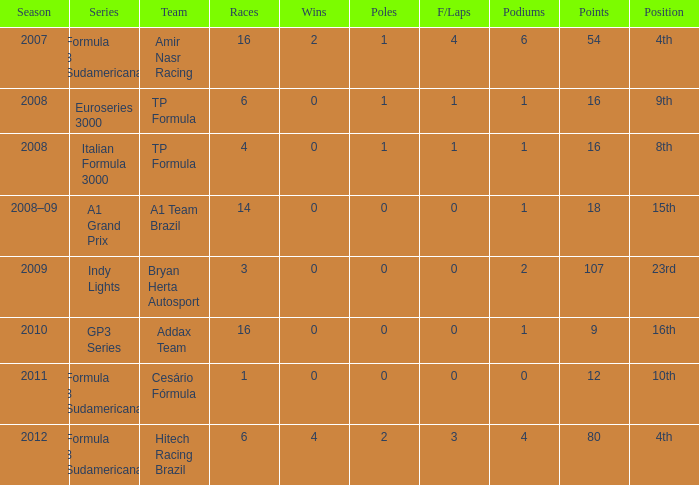How many points did he win in the race with more than 1.0 poles? 80.0. 